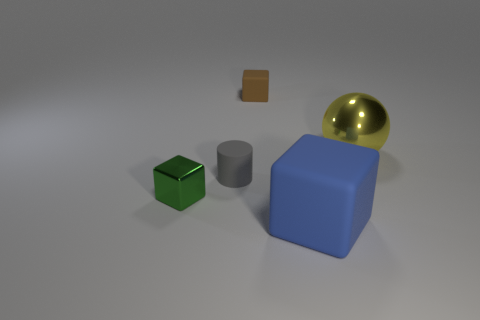Subtract all brown cubes. How many cubes are left? 2 Add 1 tiny cyan matte blocks. How many objects exist? 6 Subtract all green cubes. How many cubes are left? 2 Subtract all spheres. How many objects are left? 4 Subtract 0 brown cylinders. How many objects are left? 5 Subtract all cyan cubes. Subtract all blue cylinders. How many cubes are left? 3 Subtract all small purple shiny blocks. Subtract all big yellow objects. How many objects are left? 4 Add 4 gray cylinders. How many gray cylinders are left? 5 Add 4 purple blocks. How many purple blocks exist? 4 